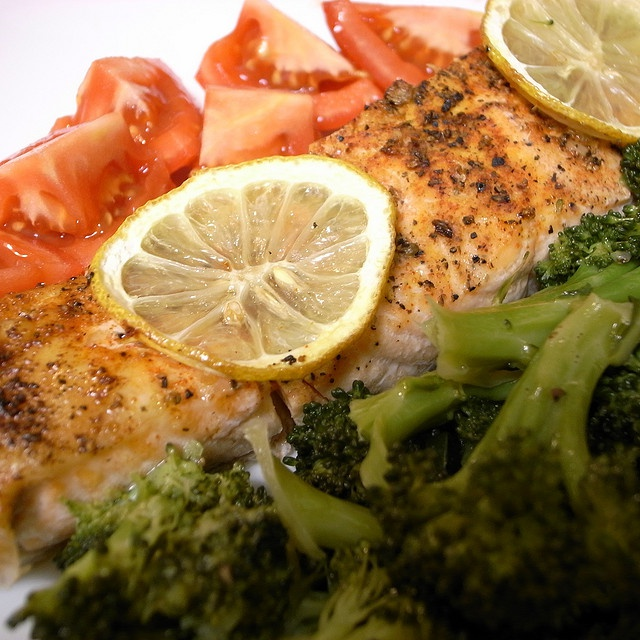Describe the objects in this image and their specific colors. I can see broccoli in lavender, black, olive, and darkgreen tones, orange in lavender, tan, and beige tones, broccoli in lavender, black, olive, and darkgreen tones, broccoli in lavender, black, and olive tones, and broccoli in lavender, olive, and black tones in this image. 